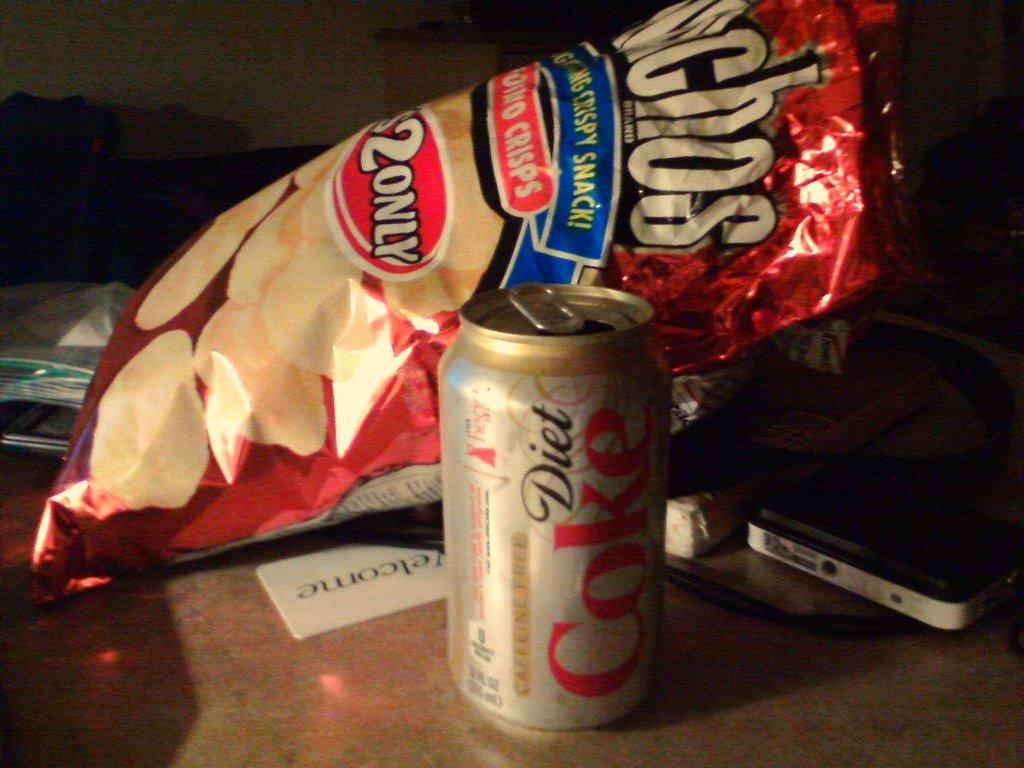<image>
Relay a brief, clear account of the picture shown. A diet Coke and a bag of Munchos on a table. 